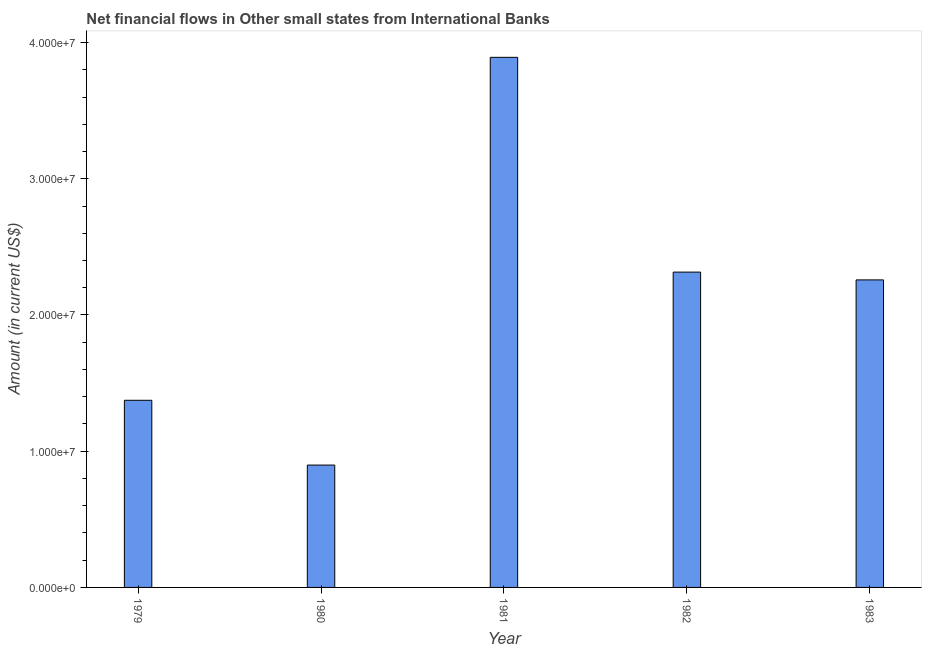Does the graph contain any zero values?
Make the answer very short. No. Does the graph contain grids?
Your answer should be very brief. No. What is the title of the graph?
Offer a very short reply. Net financial flows in Other small states from International Banks. What is the label or title of the Y-axis?
Offer a terse response. Amount (in current US$). What is the net financial flows from ibrd in 1979?
Provide a short and direct response. 1.37e+07. Across all years, what is the maximum net financial flows from ibrd?
Your response must be concise. 3.89e+07. Across all years, what is the minimum net financial flows from ibrd?
Your answer should be very brief. 8.98e+06. In which year was the net financial flows from ibrd maximum?
Give a very brief answer. 1981. What is the sum of the net financial flows from ibrd?
Your answer should be compact. 1.07e+08. What is the difference between the net financial flows from ibrd in 1982 and 1983?
Make the answer very short. 5.73e+05. What is the average net financial flows from ibrd per year?
Make the answer very short. 2.15e+07. What is the median net financial flows from ibrd?
Your answer should be very brief. 2.26e+07. In how many years, is the net financial flows from ibrd greater than 16000000 US$?
Your answer should be compact. 3. Do a majority of the years between 1979 and 1981 (inclusive) have net financial flows from ibrd greater than 10000000 US$?
Offer a terse response. Yes. What is the ratio of the net financial flows from ibrd in 1980 to that in 1982?
Your answer should be compact. 0.39. Is the difference between the net financial flows from ibrd in 1979 and 1981 greater than the difference between any two years?
Your response must be concise. No. What is the difference between the highest and the second highest net financial flows from ibrd?
Your answer should be compact. 1.58e+07. Is the sum of the net financial flows from ibrd in 1980 and 1982 greater than the maximum net financial flows from ibrd across all years?
Offer a very short reply. No. What is the difference between the highest and the lowest net financial flows from ibrd?
Provide a short and direct response. 2.99e+07. In how many years, is the net financial flows from ibrd greater than the average net financial flows from ibrd taken over all years?
Offer a very short reply. 3. How many bars are there?
Give a very brief answer. 5. What is the difference between two consecutive major ticks on the Y-axis?
Your answer should be compact. 1.00e+07. What is the Amount (in current US$) of 1979?
Ensure brevity in your answer.  1.37e+07. What is the Amount (in current US$) in 1980?
Offer a terse response. 8.98e+06. What is the Amount (in current US$) of 1981?
Make the answer very short. 3.89e+07. What is the Amount (in current US$) in 1982?
Offer a very short reply. 2.31e+07. What is the Amount (in current US$) of 1983?
Your response must be concise. 2.26e+07. What is the difference between the Amount (in current US$) in 1979 and 1980?
Keep it short and to the point. 4.76e+06. What is the difference between the Amount (in current US$) in 1979 and 1981?
Your response must be concise. -2.52e+07. What is the difference between the Amount (in current US$) in 1979 and 1982?
Make the answer very short. -9.41e+06. What is the difference between the Amount (in current US$) in 1979 and 1983?
Your response must be concise. -8.84e+06. What is the difference between the Amount (in current US$) in 1980 and 1981?
Offer a very short reply. -2.99e+07. What is the difference between the Amount (in current US$) in 1980 and 1982?
Your response must be concise. -1.42e+07. What is the difference between the Amount (in current US$) in 1980 and 1983?
Offer a terse response. -1.36e+07. What is the difference between the Amount (in current US$) in 1981 and 1982?
Your answer should be very brief. 1.58e+07. What is the difference between the Amount (in current US$) in 1981 and 1983?
Keep it short and to the point. 1.63e+07. What is the difference between the Amount (in current US$) in 1982 and 1983?
Offer a very short reply. 5.73e+05. What is the ratio of the Amount (in current US$) in 1979 to that in 1980?
Keep it short and to the point. 1.53. What is the ratio of the Amount (in current US$) in 1979 to that in 1981?
Keep it short and to the point. 0.35. What is the ratio of the Amount (in current US$) in 1979 to that in 1982?
Make the answer very short. 0.59. What is the ratio of the Amount (in current US$) in 1979 to that in 1983?
Ensure brevity in your answer.  0.61. What is the ratio of the Amount (in current US$) in 1980 to that in 1981?
Provide a short and direct response. 0.23. What is the ratio of the Amount (in current US$) in 1980 to that in 1982?
Provide a short and direct response. 0.39. What is the ratio of the Amount (in current US$) in 1980 to that in 1983?
Give a very brief answer. 0.4. What is the ratio of the Amount (in current US$) in 1981 to that in 1982?
Your response must be concise. 1.68. What is the ratio of the Amount (in current US$) in 1981 to that in 1983?
Offer a very short reply. 1.72. 